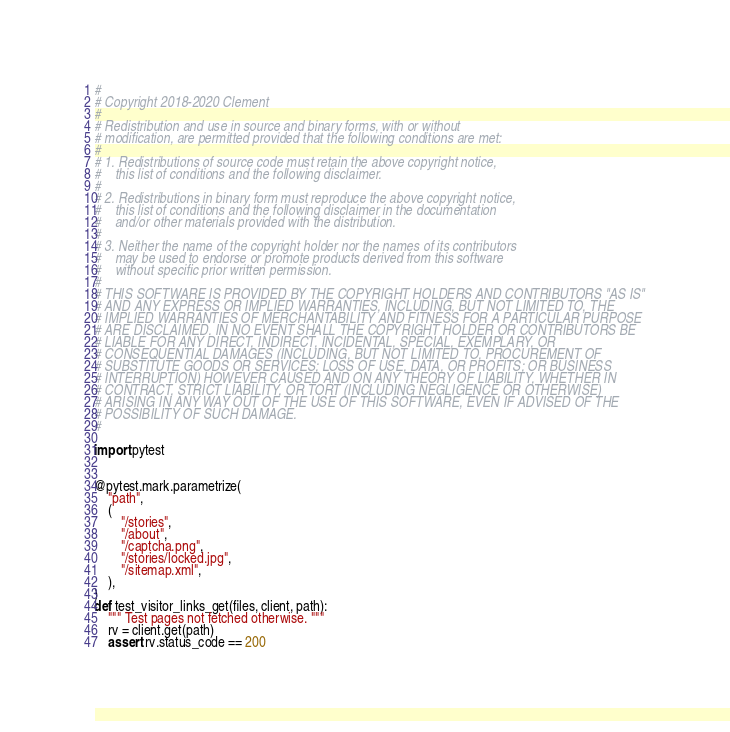<code> <loc_0><loc_0><loc_500><loc_500><_Python_>#
# Copyright 2018-2020 Clement
#
# Redistribution and use in source and binary forms, with or without
# modification, are permitted provided that the following conditions are met:
#
# 1. Redistributions of source code must retain the above copyright notice,
#    this list of conditions and the following disclaimer.
#
# 2. Redistributions in binary form must reproduce the above copyright notice,
#    this list of conditions and the following disclaimer in the documentation
#    and/or other materials provided with the distribution.
#
# 3. Neither the name of the copyright holder nor the names of its contributors
#    may be used to endorse or promote products derived from this software
#    without specific prior written permission.
#
# THIS SOFTWARE IS PROVIDED BY THE COPYRIGHT HOLDERS AND CONTRIBUTORS "AS IS"
# AND ANY EXPRESS OR IMPLIED WARRANTIES, INCLUDING, BUT NOT LIMITED TO, THE
# IMPLIED WARRANTIES OF MERCHANTABILITY AND FITNESS FOR A PARTICULAR PURPOSE
# ARE DISCLAIMED. IN NO EVENT SHALL THE COPYRIGHT HOLDER OR CONTRIBUTORS BE
# LIABLE FOR ANY DIRECT, INDIRECT, INCIDENTAL, SPECIAL, EXEMPLARY, OR
# CONSEQUENTIAL DAMAGES (INCLUDING, BUT NOT LIMITED TO, PROCUREMENT OF
# SUBSTITUTE GOODS OR SERVICES; LOSS OF USE, DATA, OR PROFITS; OR BUSINESS
# INTERRUPTION) HOWEVER CAUSED AND ON ANY THEORY OF LIABILITY, WHETHER IN
# CONTRACT, STRICT LIABILITY, OR TORT (INCLUDING NEGLIGENCE OR OTHERWISE)
# ARISING IN ANY WAY OUT OF THE USE OF THIS SOFTWARE, EVEN IF ADVISED OF THE
# POSSIBILITY OF SUCH DAMAGE.
#

import pytest


@pytest.mark.parametrize(
    "path",
    (
        "/stories",
        "/about",
        "/captcha.png",
        "/stories/locked.jpg",
        "/sitemap.xml",
    ),
)
def test_visitor_links_get(files, client, path):
    """ Test pages not fetched otherwise. """
    rv = client.get(path)
    assert rv.status_code == 200
</code> 